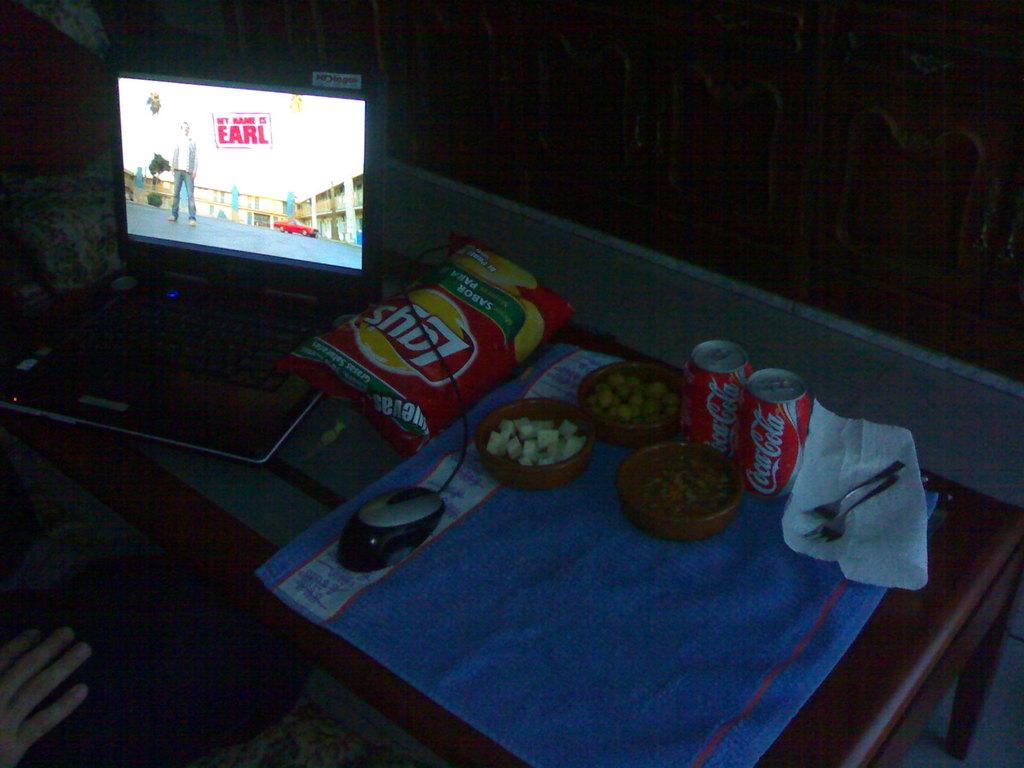What is the brand of chips?
Offer a terse response. Lays. 